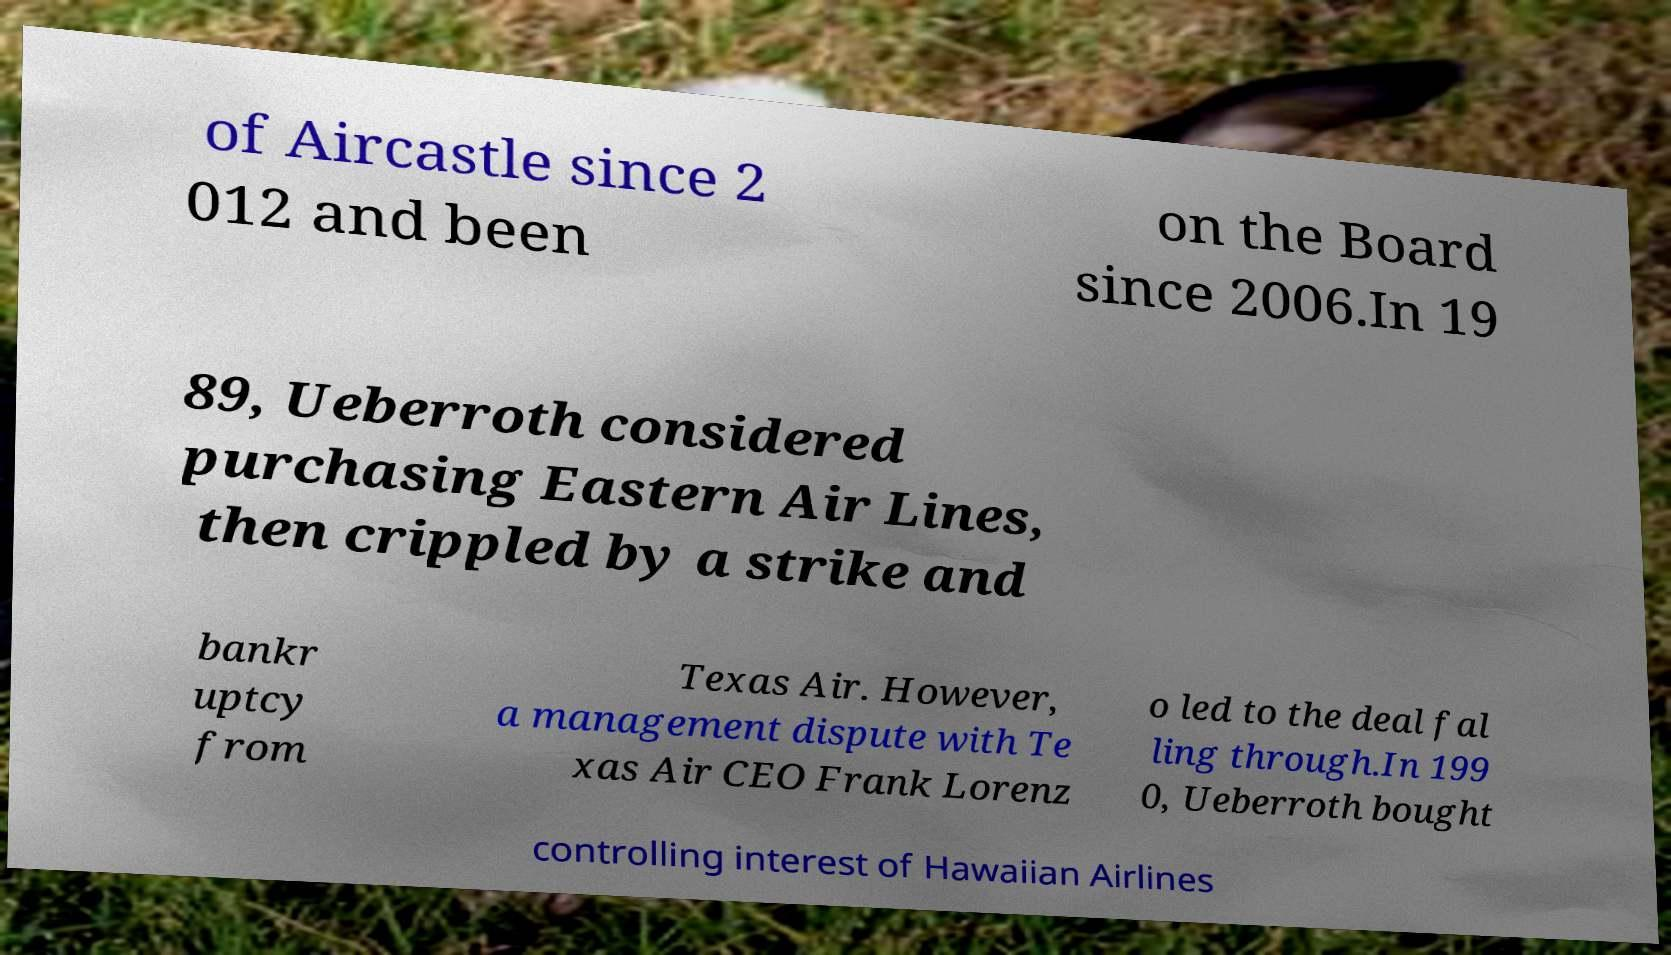Can you accurately transcribe the text from the provided image for me? of Aircastle since 2 012 and been on the Board since 2006.In 19 89, Ueberroth considered purchasing Eastern Air Lines, then crippled by a strike and bankr uptcy from Texas Air. However, a management dispute with Te xas Air CEO Frank Lorenz o led to the deal fal ling through.In 199 0, Ueberroth bought controlling interest of Hawaiian Airlines 